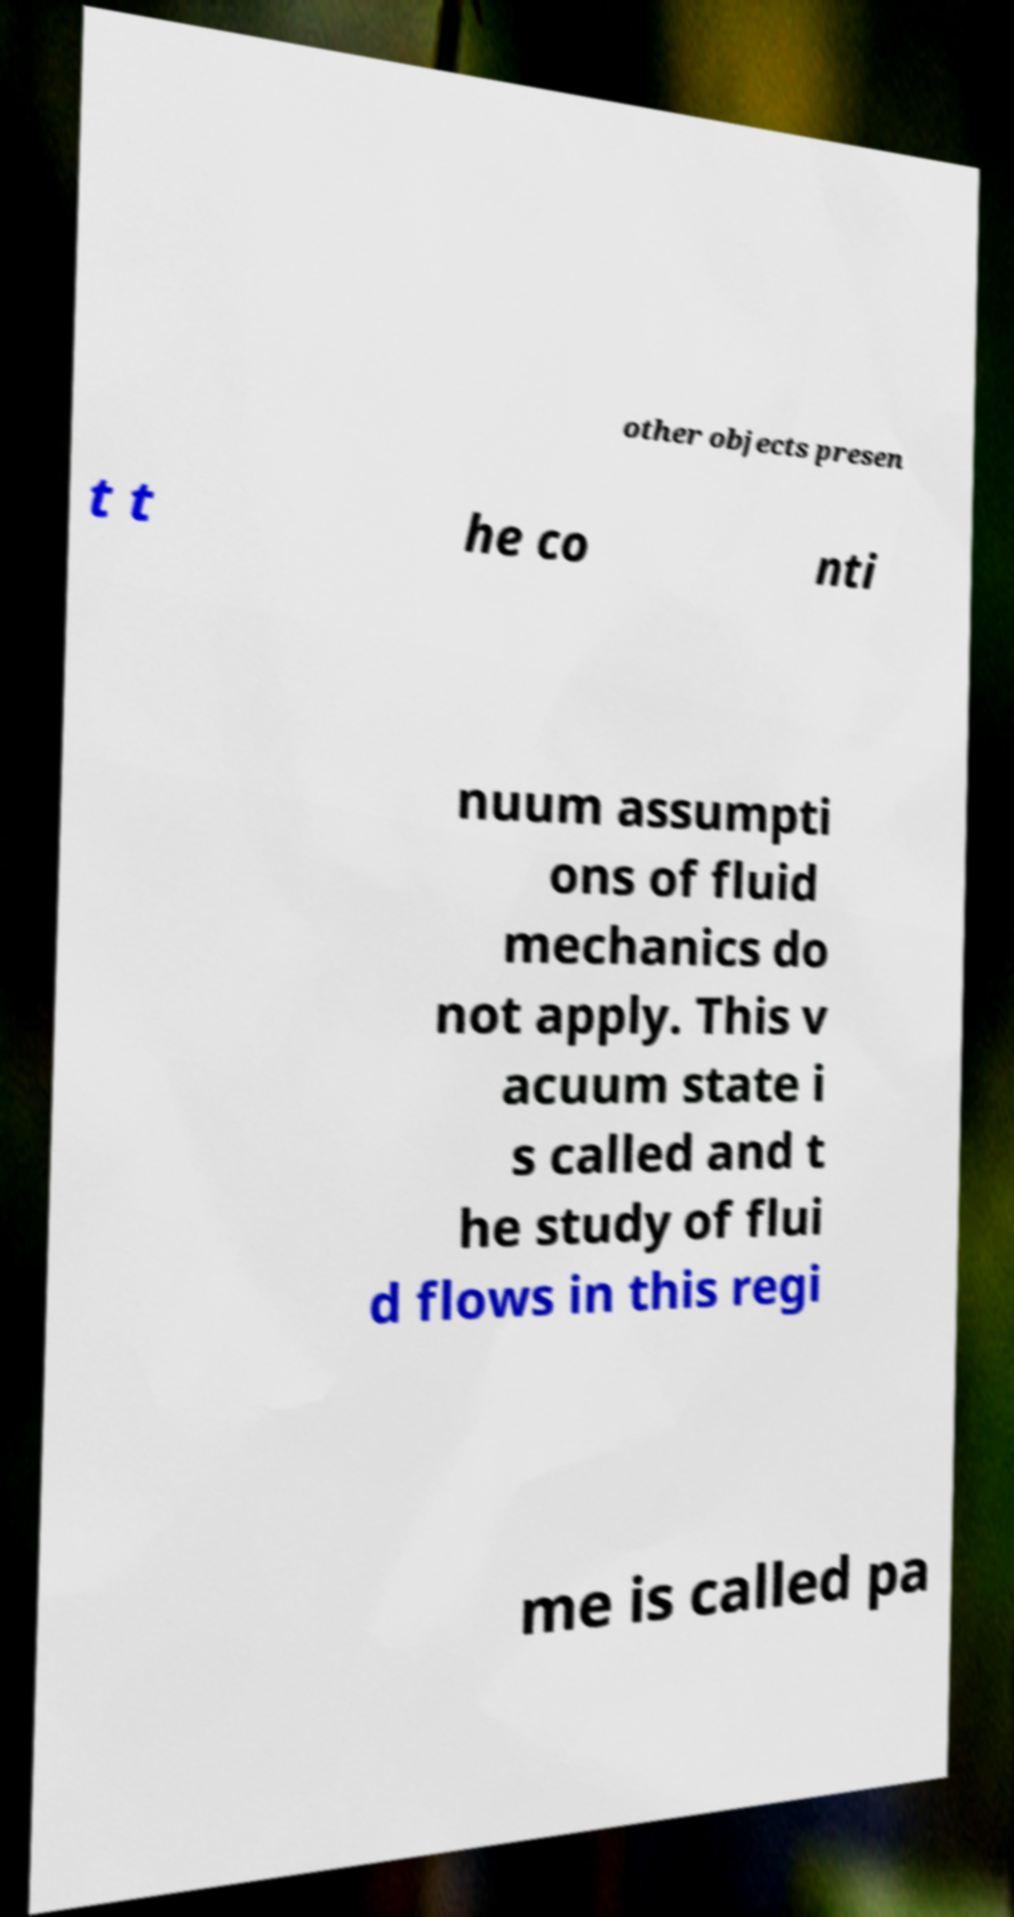Please read and relay the text visible in this image. What does it say? other objects presen t t he co nti nuum assumpti ons of fluid mechanics do not apply. This v acuum state i s called and t he study of flui d flows in this regi me is called pa 